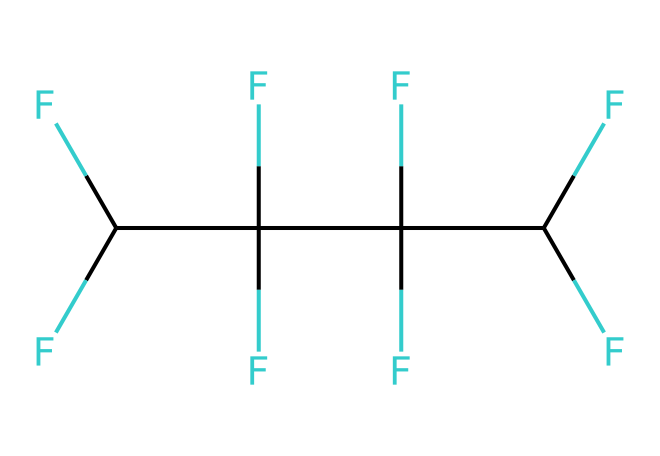What is the name of the chemical represented by the SMILES? The SMILES representation corresponds to a structure known for its high fluorine content and is commonly referred to as polytetrafluoroethylene (PTFE).
Answer: polytetrafluoroethylene How many carbon atoms are in PTFE? The SMILES indicates there are four carbon atoms connected in the chain, as seen from the repeating unit of 'C' in the representation.
Answer: four What is the total number of fluorine atoms in this chemical? Each carbon in the structure is bonded to two fluorine atoms, and with four carbons, the total number of fluorine atoms is eight (4 carbon atoms x 2 fluorine atoms each).
Answer: eight What impact does the fluorine content have on PTFE's properties? The high fluorine content imparts characteristics such as high chemical resistance and low friction, resulting in superior non-stick properties, which makes it ideal for lubricants and coatings.
Answer: high chemical resistance Is PTFE a good lubricant in non-stick applications? Yes, PTFE is renowned for its low friction characteristics that make it excellent for non-stick applications in various industrial and household items.
Answer: yes What type of bonding is prevalent in the structure of PTFE? The structure primarily features covalent bonding between carbon and fluorine atoms, which contributes to its stability and unique properties.
Answer: covalent bonding 